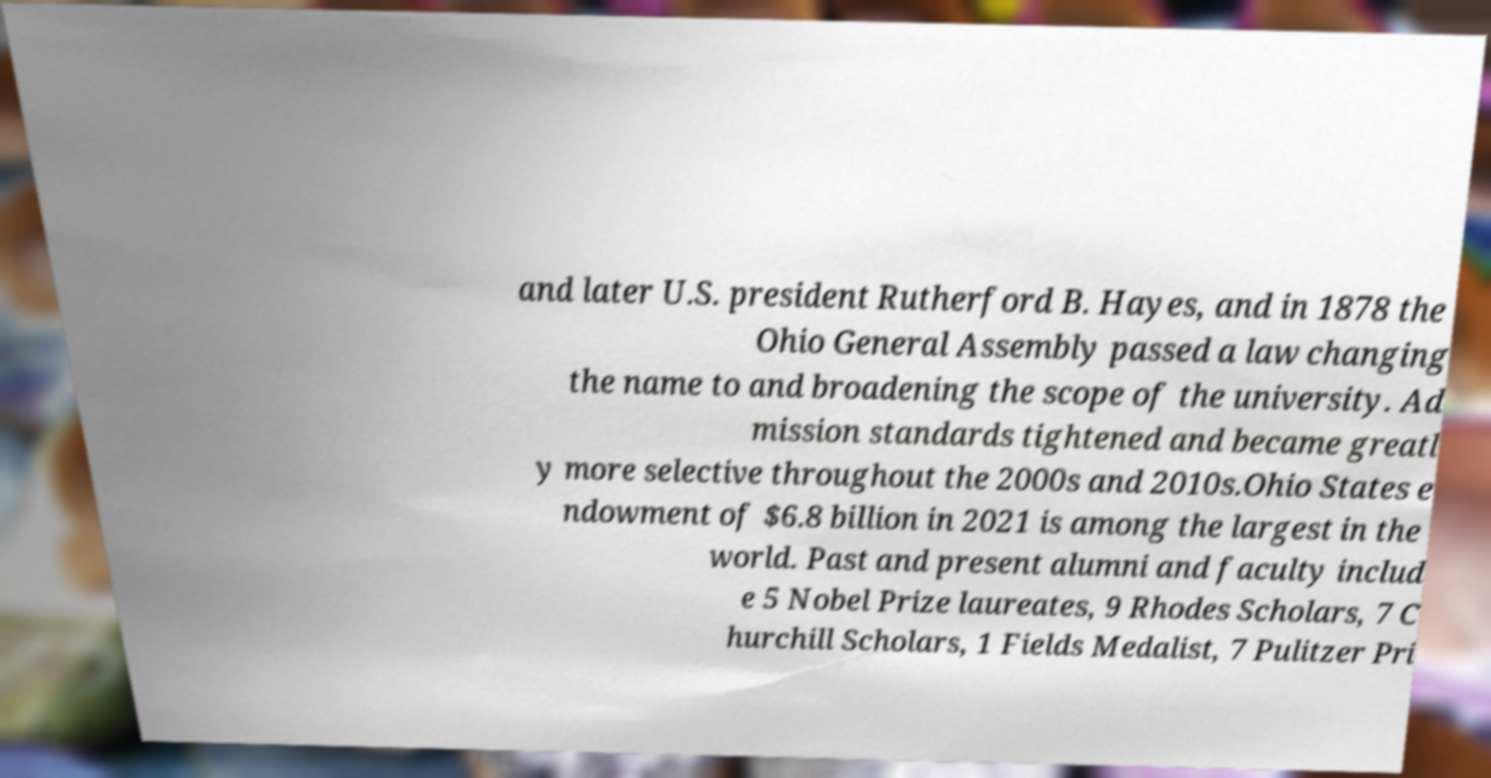There's text embedded in this image that I need extracted. Can you transcribe it verbatim? and later U.S. president Rutherford B. Hayes, and in 1878 the Ohio General Assembly passed a law changing the name to and broadening the scope of the university. Ad mission standards tightened and became greatl y more selective throughout the 2000s and 2010s.Ohio States e ndowment of $6.8 billion in 2021 is among the largest in the world. Past and present alumni and faculty includ e 5 Nobel Prize laureates, 9 Rhodes Scholars, 7 C hurchill Scholars, 1 Fields Medalist, 7 Pulitzer Pri 